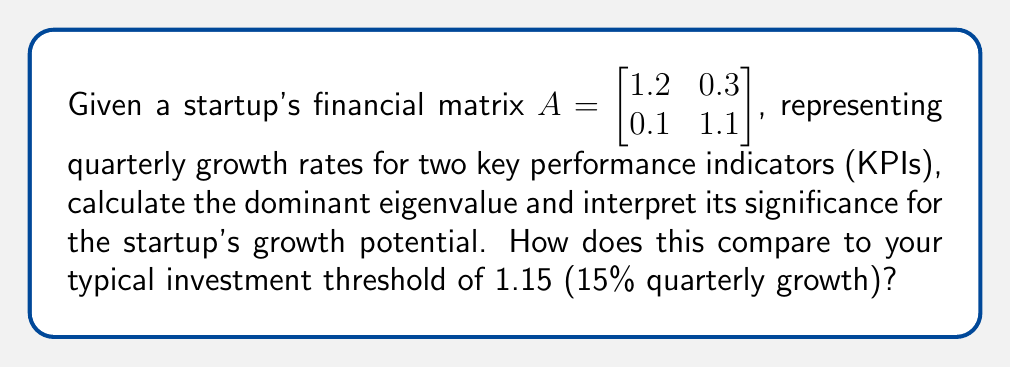Can you answer this question? To analyze the startup's growth potential, we need to find the eigenvalues of matrix $A$ and focus on the dominant (largest) eigenvalue.

Step 1: Set up the characteristic equation
$$det(A - \lambda I) = 0$$
$$\begin{vmatrix} 1.2 - \lambda & 0.3 \\ 0.1 & 1.1 - \lambda \end{vmatrix} = 0$$

Step 2: Expand the determinant
$$(1.2 - \lambda)(1.1 - \lambda) - (0.3)(0.1) = 0$$
$$\lambda^2 - 2.3\lambda + 1.29 = 0$$

Step 3: Solve the quadratic equation
Using the quadratic formula $\lambda = \frac{-b \pm \sqrt{b^2 - 4ac}}{2a}$:

$$\lambda = \frac{2.3 \pm \sqrt{2.3^2 - 4(1)(1.29)}}{2(1)}$$
$$\lambda = \frac{2.3 \pm \sqrt{5.29 - 5.16}}{2}$$
$$\lambda = \frac{2.3 \pm \sqrt{0.13}}{2}$$
$$\lambda = \frac{2.3 \pm 0.36}{2}$$

The two eigenvalues are:
$$\lambda_1 = \frac{2.3 + 0.36}{2} \approx 1.33$$
$$\lambda_2 = \frac{2.3 - 0.36}{2} \approx 0.97$$

Step 4: Interpret the results
The dominant eigenvalue is $\lambda_1 \approx 1.33$, which represents the startup's overall growth rate. This indicates a quarterly growth rate of approximately 33%, which is significantly higher than the typical investment threshold of 1.15 (15% quarterly growth).

The dominant eigenvalue suggests strong growth potential for the startup, as it outperforms the investment threshold by a considerable margin.
Answer: $\lambda_1 \approx 1.33$, indicating 33% quarterly growth and strong potential exceeding the 15% threshold. 